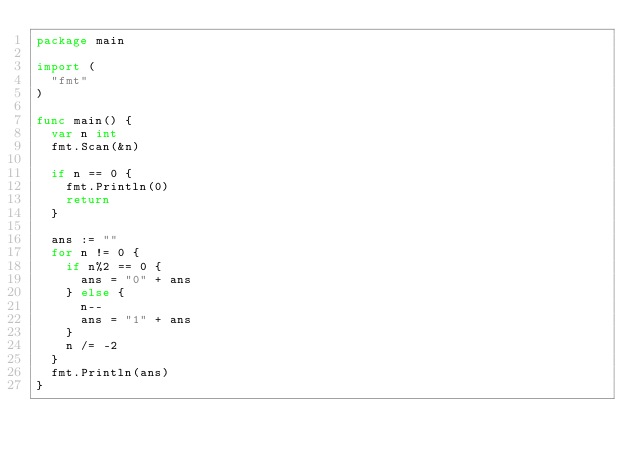<code> <loc_0><loc_0><loc_500><loc_500><_Go_>package main

import (
	"fmt"
)

func main() {
	var n int
	fmt.Scan(&n)

	if n == 0 {
		fmt.Println(0)
		return
	}

	ans := ""
	for n != 0 {
		if n%2 == 0 {
			ans = "0" + ans
		} else {
			n--
			ans = "1" + ans
		}
		n /= -2
	}
	fmt.Println(ans)
}
</code> 